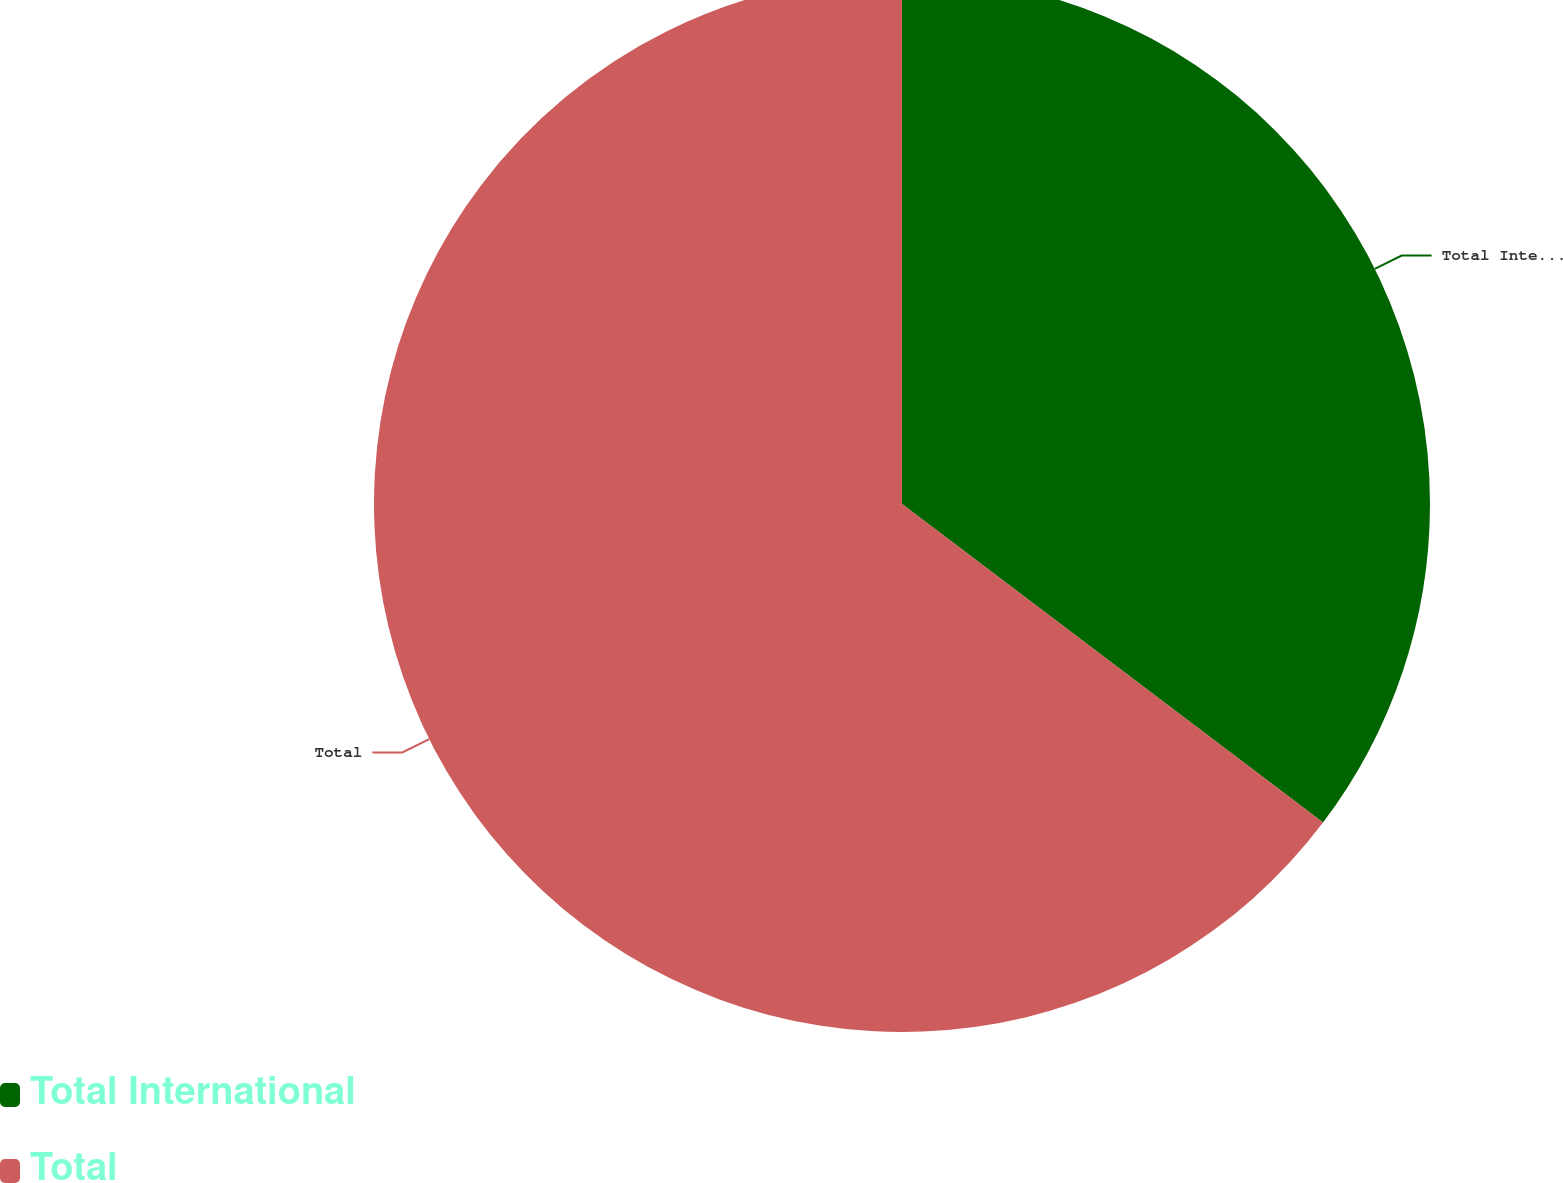Convert chart. <chart><loc_0><loc_0><loc_500><loc_500><pie_chart><fcel>Total International<fcel>Total<nl><fcel>35.31%<fcel>64.69%<nl></chart> 